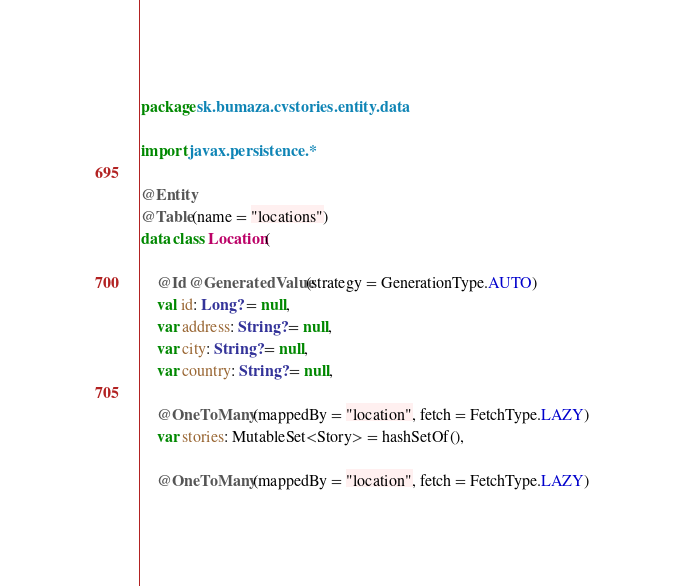Convert code to text. <code><loc_0><loc_0><loc_500><loc_500><_Kotlin_>package sk.bumaza.cvstories.entity.data

import javax.persistence.*

@Entity
@Table(name = "locations")
data class Location(

    @Id @GeneratedValue(strategy = GenerationType.AUTO)
    val id: Long? = null,
    var address: String? = null,
    var city: String? = null,
    var country: String? = null,

    @OneToMany(mappedBy = "location", fetch = FetchType.LAZY)
    var stories: MutableSet<Story> = hashSetOf(),

    @OneToMany(mappedBy = "location", fetch = FetchType.LAZY)</code> 